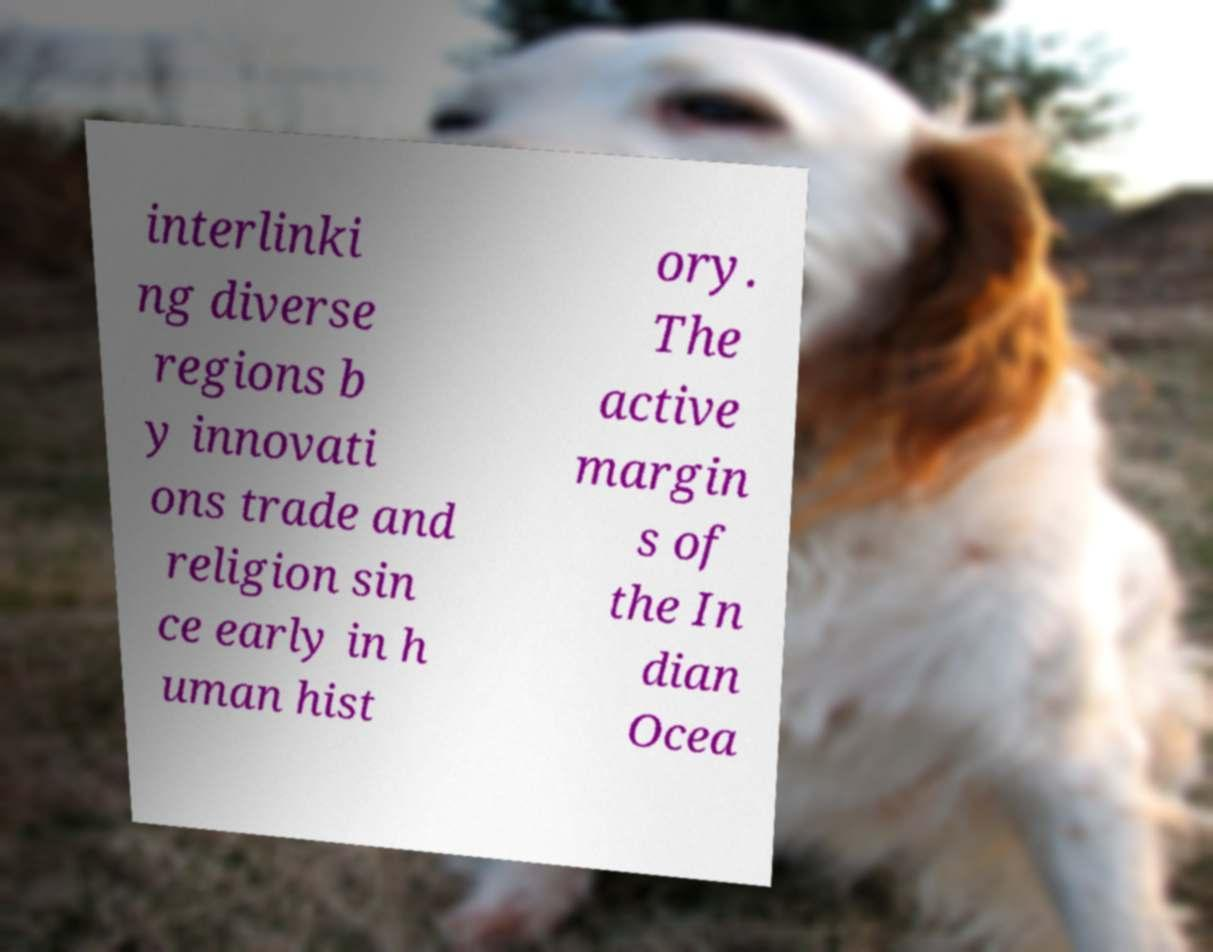Please identify and transcribe the text found in this image. interlinki ng diverse regions b y innovati ons trade and religion sin ce early in h uman hist ory. The active margin s of the In dian Ocea 